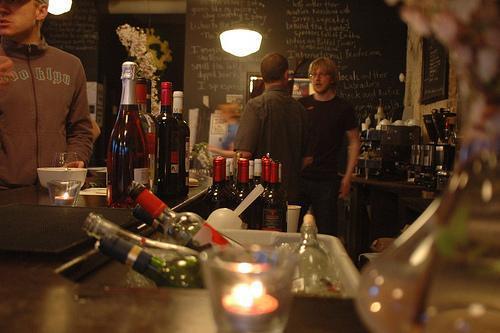How many ceiling lights are visible?
Give a very brief answer. 2. How many lights are there?
Give a very brief answer. 2. How many people?
Give a very brief answer. 4. How many bottles of wine on the bar?
Give a very brief answer. 4. How many men are talking behind the bar?
Give a very brief answer. 2. 